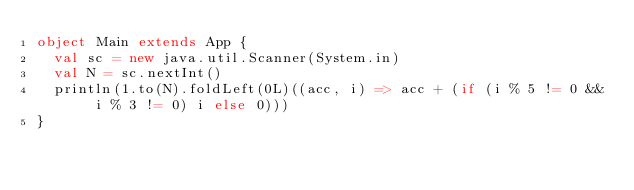Convert code to text. <code><loc_0><loc_0><loc_500><loc_500><_Scala_>object Main extends App {
  val sc = new java.util.Scanner(System.in)
  val N = sc.nextInt()
  println(1.to(N).foldLeft(0L)((acc, i) => acc + (if (i % 5 != 0 && i % 3 != 0) i else 0)))
}
</code> 